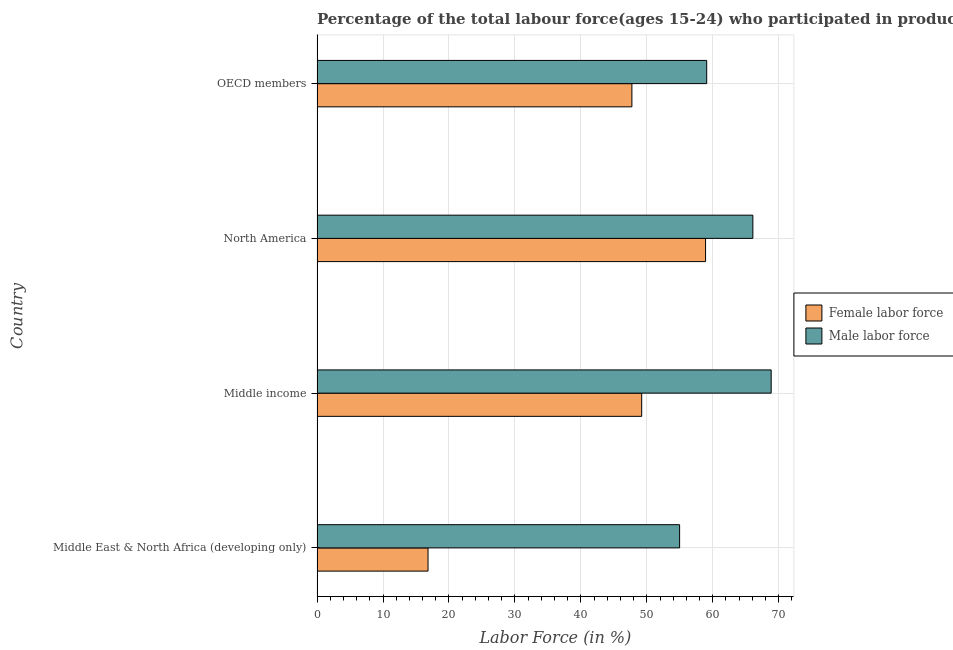How many bars are there on the 2nd tick from the bottom?
Provide a short and direct response. 2. What is the label of the 1st group of bars from the top?
Your answer should be very brief. OECD members. In how many cases, is the number of bars for a given country not equal to the number of legend labels?
Make the answer very short. 0. What is the percentage of male labour force in Middle East & North Africa (developing only)?
Ensure brevity in your answer.  54.97. Across all countries, what is the maximum percentage of male labour force?
Provide a short and direct response. 68.85. Across all countries, what is the minimum percentage of male labour force?
Keep it short and to the point. 54.97. In which country was the percentage of male labour force minimum?
Provide a succinct answer. Middle East & North Africa (developing only). What is the total percentage of male labour force in the graph?
Make the answer very short. 248.97. What is the difference between the percentage of female labor force in North America and that in OECD members?
Provide a succinct answer. 11.17. What is the difference between the percentage of female labor force in North America and the percentage of male labour force in Middle East & North Africa (developing only)?
Your answer should be very brief. 3.94. What is the average percentage of male labour force per country?
Keep it short and to the point. 62.24. What is the difference between the percentage of female labor force and percentage of male labour force in Middle East & North Africa (developing only)?
Keep it short and to the point. -38.14. In how many countries, is the percentage of male labour force greater than 34 %?
Offer a terse response. 4. What is the ratio of the percentage of female labor force in Middle income to that in North America?
Your response must be concise. 0.84. Is the difference between the percentage of female labor force in North America and OECD members greater than the difference between the percentage of male labour force in North America and OECD members?
Offer a very short reply. Yes. What is the difference between the highest and the second highest percentage of male labour force?
Offer a terse response. 2.78. What is the difference between the highest and the lowest percentage of female labor force?
Make the answer very short. 42.08. In how many countries, is the percentage of female labor force greater than the average percentage of female labor force taken over all countries?
Your response must be concise. 3. What does the 1st bar from the top in Middle income represents?
Your answer should be compact. Male labor force. What does the 2nd bar from the bottom in North America represents?
Offer a terse response. Male labor force. Does the graph contain any zero values?
Ensure brevity in your answer.  No. Does the graph contain grids?
Your answer should be compact. Yes. How are the legend labels stacked?
Give a very brief answer. Vertical. What is the title of the graph?
Make the answer very short. Percentage of the total labour force(ages 15-24) who participated in production in 1992. What is the label or title of the X-axis?
Ensure brevity in your answer.  Labor Force (in %). What is the label or title of the Y-axis?
Ensure brevity in your answer.  Country. What is the Labor Force (in %) in Female labor force in Middle East & North Africa (developing only)?
Ensure brevity in your answer.  16.83. What is the Labor Force (in %) in Male labor force in Middle East & North Africa (developing only)?
Offer a very short reply. 54.97. What is the Labor Force (in %) in Female labor force in Middle income?
Your answer should be very brief. 49.22. What is the Labor Force (in %) of Male labor force in Middle income?
Provide a succinct answer. 68.85. What is the Labor Force (in %) in Female labor force in North America?
Your response must be concise. 58.9. What is the Labor Force (in %) in Male labor force in North America?
Keep it short and to the point. 66.08. What is the Labor Force (in %) of Female labor force in OECD members?
Offer a terse response. 47.73. What is the Labor Force (in %) in Male labor force in OECD members?
Provide a succinct answer. 59.08. Across all countries, what is the maximum Labor Force (in %) in Female labor force?
Offer a terse response. 58.9. Across all countries, what is the maximum Labor Force (in %) in Male labor force?
Your answer should be compact. 68.85. Across all countries, what is the minimum Labor Force (in %) in Female labor force?
Offer a very short reply. 16.83. Across all countries, what is the minimum Labor Force (in %) of Male labor force?
Provide a succinct answer. 54.97. What is the total Labor Force (in %) in Female labor force in the graph?
Provide a short and direct response. 172.68. What is the total Labor Force (in %) in Male labor force in the graph?
Ensure brevity in your answer.  248.97. What is the difference between the Labor Force (in %) of Female labor force in Middle East & North Africa (developing only) and that in Middle income?
Keep it short and to the point. -32.39. What is the difference between the Labor Force (in %) in Male labor force in Middle East & North Africa (developing only) and that in Middle income?
Make the answer very short. -13.88. What is the difference between the Labor Force (in %) in Female labor force in Middle East & North Africa (developing only) and that in North America?
Ensure brevity in your answer.  -42.08. What is the difference between the Labor Force (in %) in Male labor force in Middle East & North Africa (developing only) and that in North America?
Make the answer very short. -11.11. What is the difference between the Labor Force (in %) of Female labor force in Middle East & North Africa (developing only) and that in OECD members?
Your response must be concise. -30.91. What is the difference between the Labor Force (in %) of Male labor force in Middle East & North Africa (developing only) and that in OECD members?
Offer a terse response. -4.11. What is the difference between the Labor Force (in %) in Female labor force in Middle income and that in North America?
Offer a very short reply. -9.68. What is the difference between the Labor Force (in %) of Male labor force in Middle income and that in North America?
Your answer should be very brief. 2.78. What is the difference between the Labor Force (in %) of Female labor force in Middle income and that in OECD members?
Your answer should be very brief. 1.49. What is the difference between the Labor Force (in %) in Male labor force in Middle income and that in OECD members?
Keep it short and to the point. 9.77. What is the difference between the Labor Force (in %) in Female labor force in North America and that in OECD members?
Provide a succinct answer. 11.17. What is the difference between the Labor Force (in %) of Male labor force in North America and that in OECD members?
Ensure brevity in your answer.  7. What is the difference between the Labor Force (in %) of Female labor force in Middle East & North Africa (developing only) and the Labor Force (in %) of Male labor force in Middle income?
Offer a terse response. -52.03. What is the difference between the Labor Force (in %) of Female labor force in Middle East & North Africa (developing only) and the Labor Force (in %) of Male labor force in North America?
Ensure brevity in your answer.  -49.25. What is the difference between the Labor Force (in %) of Female labor force in Middle East & North Africa (developing only) and the Labor Force (in %) of Male labor force in OECD members?
Provide a succinct answer. -42.25. What is the difference between the Labor Force (in %) in Female labor force in Middle income and the Labor Force (in %) in Male labor force in North America?
Offer a very short reply. -16.86. What is the difference between the Labor Force (in %) in Female labor force in Middle income and the Labor Force (in %) in Male labor force in OECD members?
Offer a terse response. -9.86. What is the difference between the Labor Force (in %) in Female labor force in North America and the Labor Force (in %) in Male labor force in OECD members?
Your answer should be compact. -0.17. What is the average Labor Force (in %) of Female labor force per country?
Make the answer very short. 43.17. What is the average Labor Force (in %) in Male labor force per country?
Your answer should be very brief. 62.24. What is the difference between the Labor Force (in %) of Female labor force and Labor Force (in %) of Male labor force in Middle East & North Africa (developing only)?
Your answer should be very brief. -38.14. What is the difference between the Labor Force (in %) in Female labor force and Labor Force (in %) in Male labor force in Middle income?
Your answer should be very brief. -19.63. What is the difference between the Labor Force (in %) of Female labor force and Labor Force (in %) of Male labor force in North America?
Provide a short and direct response. -7.17. What is the difference between the Labor Force (in %) in Female labor force and Labor Force (in %) in Male labor force in OECD members?
Keep it short and to the point. -11.34. What is the ratio of the Labor Force (in %) in Female labor force in Middle East & North Africa (developing only) to that in Middle income?
Offer a terse response. 0.34. What is the ratio of the Labor Force (in %) of Male labor force in Middle East & North Africa (developing only) to that in Middle income?
Your response must be concise. 0.8. What is the ratio of the Labor Force (in %) of Female labor force in Middle East & North Africa (developing only) to that in North America?
Your response must be concise. 0.29. What is the ratio of the Labor Force (in %) in Male labor force in Middle East & North Africa (developing only) to that in North America?
Offer a very short reply. 0.83. What is the ratio of the Labor Force (in %) in Female labor force in Middle East & North Africa (developing only) to that in OECD members?
Provide a succinct answer. 0.35. What is the ratio of the Labor Force (in %) in Male labor force in Middle East & North Africa (developing only) to that in OECD members?
Your answer should be very brief. 0.93. What is the ratio of the Labor Force (in %) in Female labor force in Middle income to that in North America?
Offer a terse response. 0.84. What is the ratio of the Labor Force (in %) of Male labor force in Middle income to that in North America?
Offer a terse response. 1.04. What is the ratio of the Labor Force (in %) in Female labor force in Middle income to that in OECD members?
Your answer should be very brief. 1.03. What is the ratio of the Labor Force (in %) of Male labor force in Middle income to that in OECD members?
Your answer should be compact. 1.17. What is the ratio of the Labor Force (in %) of Female labor force in North America to that in OECD members?
Provide a succinct answer. 1.23. What is the ratio of the Labor Force (in %) in Male labor force in North America to that in OECD members?
Make the answer very short. 1.12. What is the difference between the highest and the second highest Labor Force (in %) of Female labor force?
Make the answer very short. 9.68. What is the difference between the highest and the second highest Labor Force (in %) of Male labor force?
Ensure brevity in your answer.  2.78. What is the difference between the highest and the lowest Labor Force (in %) of Female labor force?
Keep it short and to the point. 42.08. What is the difference between the highest and the lowest Labor Force (in %) in Male labor force?
Make the answer very short. 13.88. 